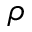Convert formula to latex. <formula><loc_0><loc_0><loc_500><loc_500>\rho</formula> 